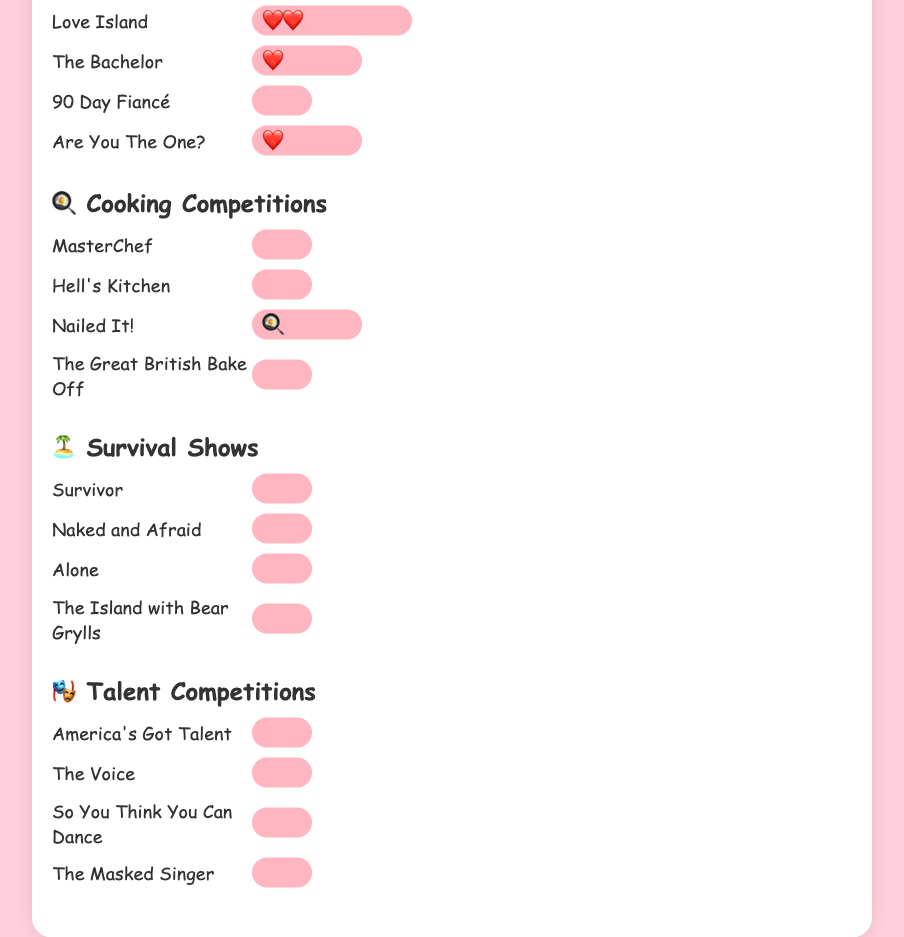Which genre uses the ❤️ emoji? The genre headings contain specific emojis associated with them. "Dating Shows" has the ❤️ emoji next to its name.
Answer: Dating Shows Which show has the highest number of emojis in the "Dating Shows" genre? Within the "Dating Shows" genre, the show "Love Island" has 2 emojis in its title, which is the highest among its peers.
Answer: Love Island How many shows in the "Cooking Competitions" genre have title emojis? Looking at the "Cooking Competitions" genre, only "Nailed It!" has an emoji in its title.
Answer: 1 Compare the total number of emojis used in the titles of Dating Shows and Survival Shows. Which genre has more emoji usage? The Dating Shows have a total of 4 emojis in the titles (Love Island: 2, The Bachelor: 1, Are You The One?: 1, 90 Day Fiancé: 0). The Survival Shows have 0 emojis in all their titles. Hence, Dating Shows have more emojis.
Answer: Dating Shows What is the sum of emoji counts for all shows in the "Talent Competitions" genre? All shows in the "Talent Competitions" genre have 0 emojis in their titles. Summing them up: 0 + 0 + 0 + 0 = 0.
Answer: 0 Which genre has no shows with emojis in their titles? By examining each genre, "Survival Shows" and "Talent Competitions" stand out with shows that have no emojis in their titles.
Answer: Survival Shows and Talent Competitions On average, how many emojis are used in the titles of Dating Shows? To calculate the average: (2 emojis for Love Island + 1 emoji for The Bachelor + 0 emojis for 90 Day Fiancé + 1 emoji for Are You The One?) / 4 shows = 4 emojis / 4 shows = 1 emoji per show.
Answer: 1 Which show in the "Cooking Competitions" genre has title emojis? Only "Nailed It!" in the Cooking Competitions genre has an emoji in its title.
Answer: Nailed It! Which genre has the least variety in emoji usage among its shows? The "Survival Shows" and "Talent Competitions" both have no variety in emoji usage as all their shows have 0 emojis. They are tied for the least variety.
Answer: Survival Shows and Talent Competitions 